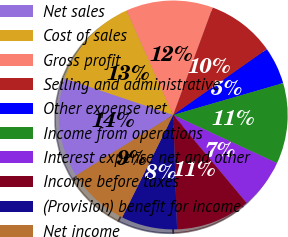<chart> <loc_0><loc_0><loc_500><loc_500><pie_chart><fcel>Net sales<fcel>Cost of sales<fcel>Gross profit<fcel>Selling and administrative<fcel>Other expense net<fcel>Income from operations<fcel>Interest expense net and other<fcel>Income before taxes<fcel>(Provision) benefit for income<fcel>Net income<nl><fcel>14.03%<fcel>13.16%<fcel>12.28%<fcel>9.65%<fcel>5.26%<fcel>11.4%<fcel>7.02%<fcel>10.53%<fcel>7.9%<fcel>8.77%<nl></chart> 